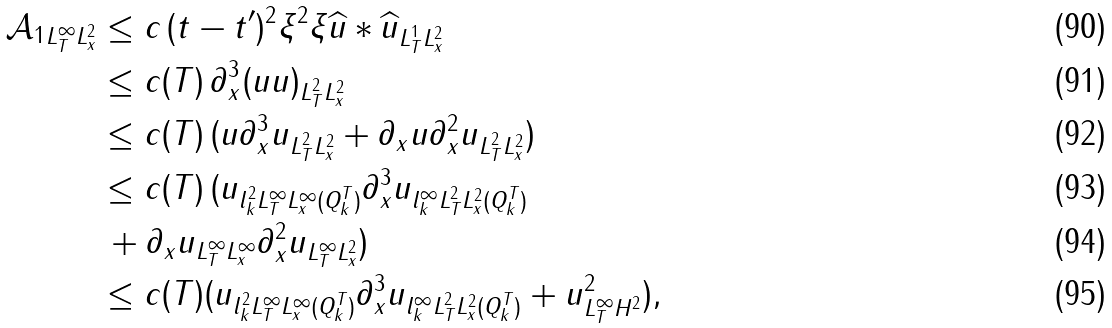<formula> <loc_0><loc_0><loc_500><loc_500>\| \mathcal { A } _ { 1 } \| _ { L _ { T } ^ { \infty } L _ { x } ^ { 2 } } & \leq c \, \| ( t - t ^ { \prime } ) ^ { 2 } \xi ^ { 2 } \xi \widehat { u } \ast \widehat { u } \| _ { L _ { T } ^ { 1 } L _ { x } ^ { 2 } } \\ & \leq c ( T ) \, \| \partial ^ { 3 } _ { x } ( u u ) \| _ { L _ { T } ^ { 2 } L _ { x } ^ { 2 } } \\ & \leq c ( T ) \, ( \| u \partial ^ { 3 } _ { x } u \| _ { L _ { T } ^ { 2 } L _ { x } ^ { 2 } } + \| \partial _ { x } u \partial ^ { 2 } _ { x } u \| _ { L _ { T } ^ { 2 } L _ { x } ^ { 2 } } ) \\ & \leq c ( T ) \, ( \| u \| _ { l _ { k } ^ { 2 } L _ { T } ^ { \infty } L _ { x } ^ { \infty } ( Q _ { k } ^ { T } ) } \| \partial ^ { 3 } _ { x } u \| _ { l _ { k } ^ { \infty } L _ { T } ^ { 2 } L _ { x } ^ { 2 } ( Q _ { k } ^ { T } ) } \\ & \, + \| \partial _ { x } u \| _ { L _ { T } ^ { \infty } L _ { x } ^ { \infty } } \| \partial ^ { 2 } _ { x } u \| _ { L _ { T } ^ { \infty } L _ { x } ^ { 2 } } ) \\ & \leq c ( T ) ( \| u \| _ { l _ { k } ^ { 2 } L _ { T } ^ { \infty } L _ { x } ^ { \infty } ( Q _ { k } ^ { T } ) } \| \partial ^ { 3 } _ { x } u \| _ { l _ { k } ^ { \infty } L _ { T } ^ { 2 } L _ { x } ^ { 2 } ( Q _ { k } ^ { T } ) } + \| u \| ^ { 2 } _ { L _ { T } ^ { \infty } H ^ { 2 } } ) ,</formula> 